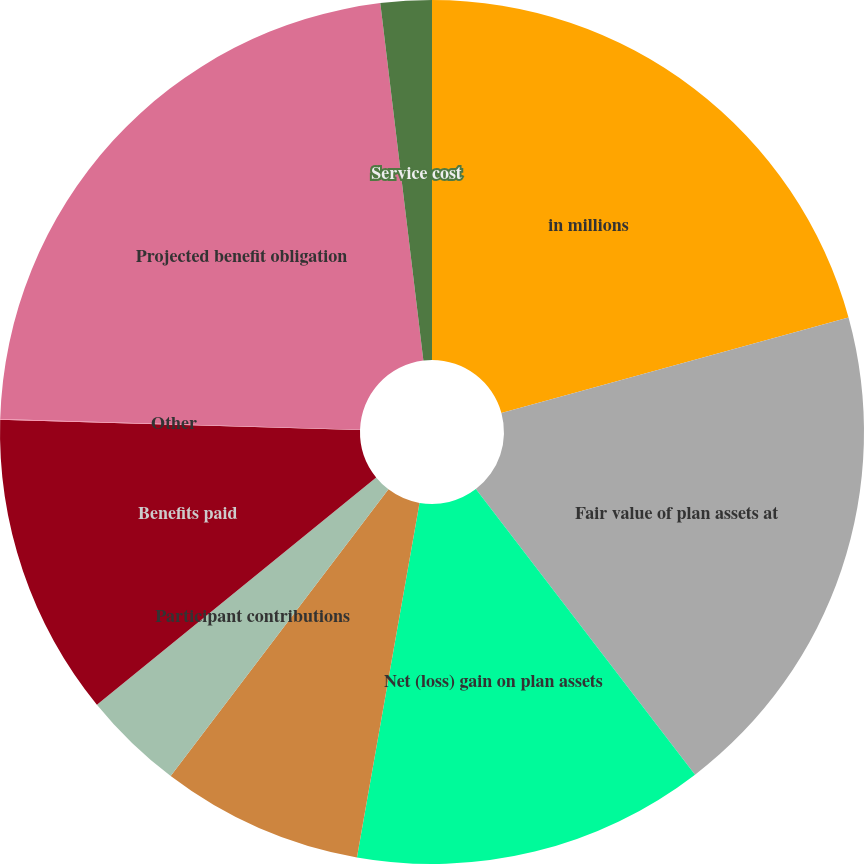Convert chart to OTSL. <chart><loc_0><loc_0><loc_500><loc_500><pie_chart><fcel>in millions<fcel>Fair value of plan assets at<fcel>Net (loss) gain on plan assets<fcel>Employer contributions<fcel>Participant contributions<fcel>Benefits paid<fcel>Other<fcel>Projected benefit obligation<fcel>Service cost<nl><fcel>20.73%<fcel>18.85%<fcel>13.2%<fcel>7.56%<fcel>3.79%<fcel>11.32%<fcel>0.03%<fcel>22.61%<fcel>1.91%<nl></chart> 